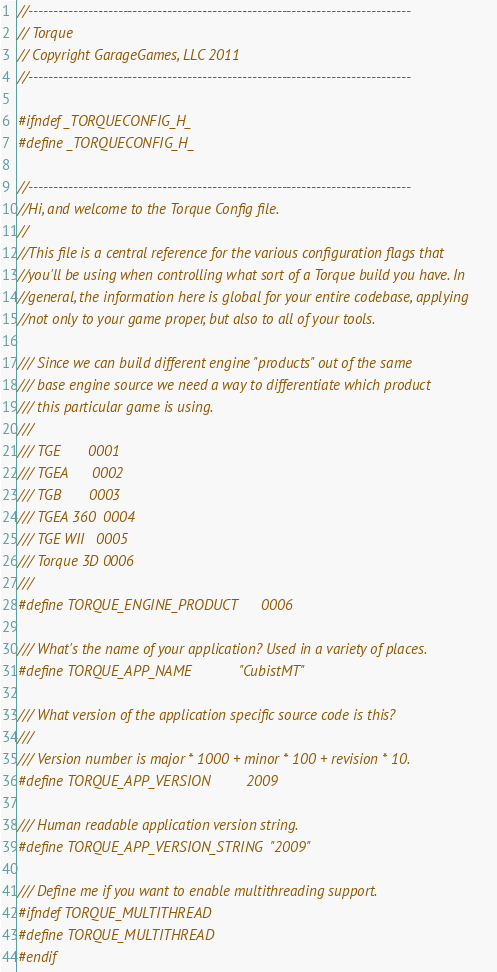Convert code to text. <code><loc_0><loc_0><loc_500><loc_500><_C_>//-----------------------------------------------------------------------------
// Torque
// Copyright GarageGames, LLC 2011
//-----------------------------------------------------------------------------

#ifndef _TORQUECONFIG_H_
#define _TORQUECONFIG_H_

//-----------------------------------------------------------------------------
//Hi, and welcome to the Torque Config file.
//
//This file is a central reference for the various configuration flags that
//you'll be using when controlling what sort of a Torque build you have. In
//general, the information here is global for your entire codebase, applying
//not only to your game proper, but also to all of your tools.

/// Since we can build different engine "products" out of the same
/// base engine source we need a way to differentiate which product
/// this particular game is using.
///
/// TGE       0001
/// TGEA      0002
/// TGB       0003
/// TGEA 360  0004
/// TGE WII   0005
/// Torque 3D 0006
///
#define TORQUE_ENGINE_PRODUCT      0006

/// What's the name of your application? Used in a variety of places.
#define TORQUE_APP_NAME            "CubistMT"

/// What version of the application specific source code is this?
///
/// Version number is major * 1000 + minor * 100 + revision * 10.
#define TORQUE_APP_VERSION         2009

/// Human readable application version string.
#define TORQUE_APP_VERSION_STRING  "2009"

/// Define me if you want to enable multithreading support.
#ifndef TORQUE_MULTITHREAD
#define TORQUE_MULTITHREAD
#endif
</code> 